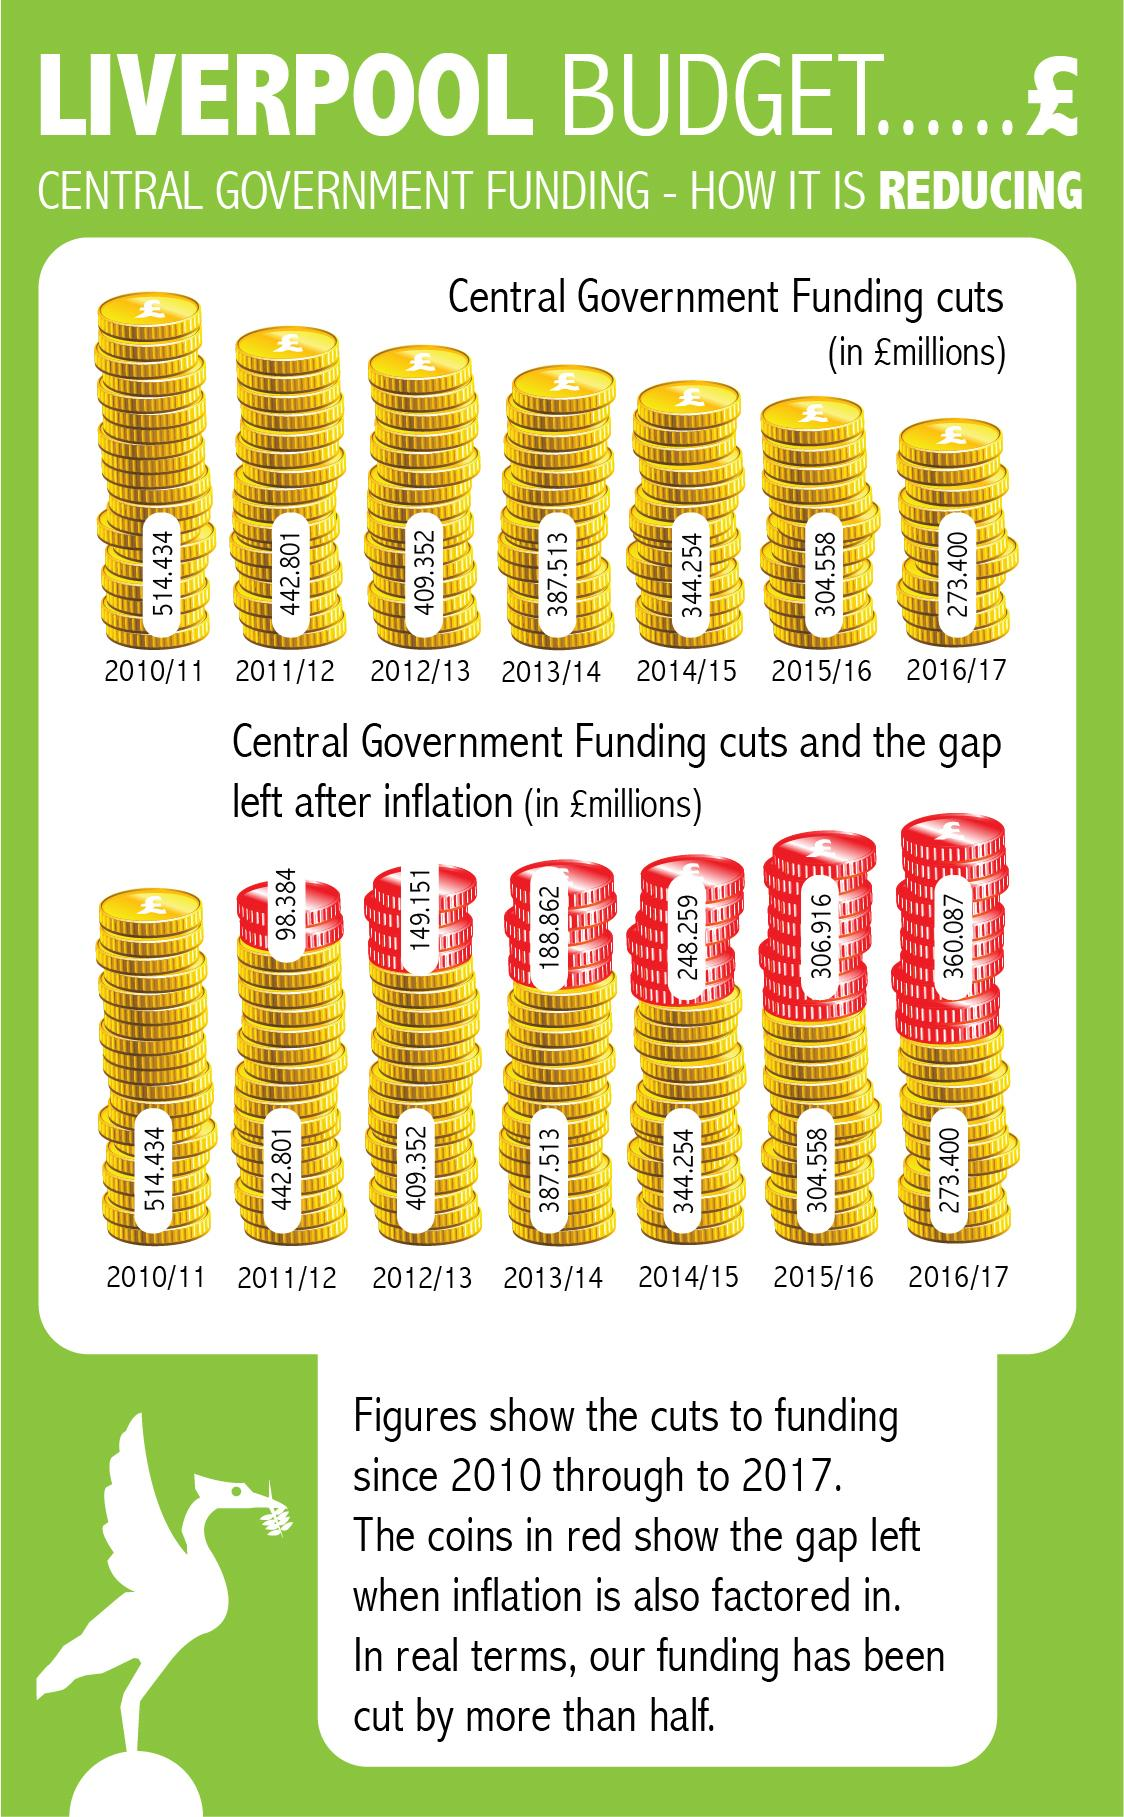Mention a couple of crucial points in this snapshot. The Central Government reduced its funding by 304.558 million during the 2015/2016 fiscal year. The gap between the number of matches won by the Indian team in the period from 2011/12 to 2016/17 and the number of matches won by the Indian team in the period from 2016/17 to 2020/21 is increasing. In the fiscal year 2011/12, the smallest gap after inflation was shown. In the 2011/2012 fiscal year, there was a gap of 98.384 million pounds. The highest gap after inflation was shown in the fiscal year 2016/17. 